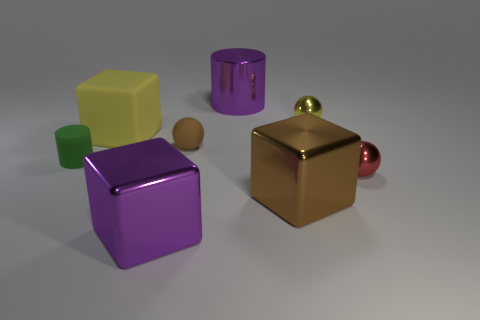Subtract 1 spheres. How many spheres are left? 2 Add 1 big yellow rubber cubes. How many objects exist? 9 Subtract all cylinders. How many objects are left? 6 Subtract all brown shiny cubes. Subtract all small red metal spheres. How many objects are left? 6 Add 8 red metallic objects. How many red metallic objects are left? 9 Add 2 yellow balls. How many yellow balls exist? 3 Subtract 0 cyan cubes. How many objects are left? 8 